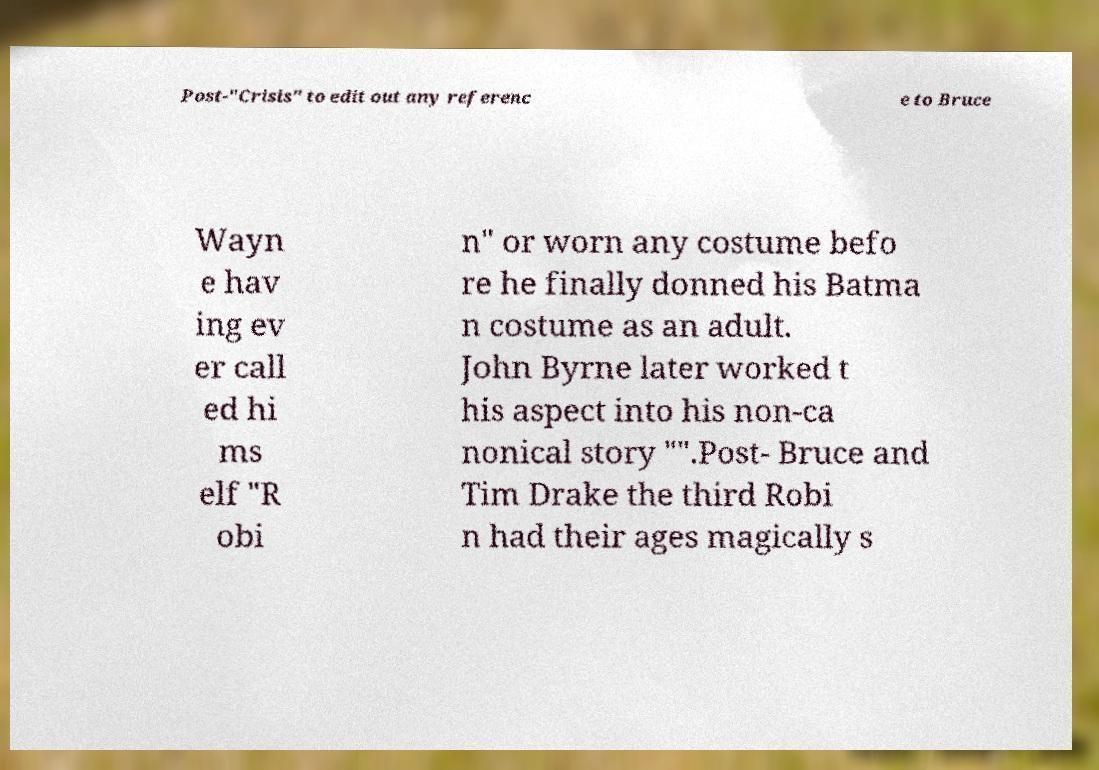Could you extract and type out the text from this image? Post-"Crisis" to edit out any referenc e to Bruce Wayn e hav ing ev er call ed hi ms elf "R obi n" or worn any costume befo re he finally donned his Batma n costume as an adult. John Byrne later worked t his aspect into his non-ca nonical story "".Post- Bruce and Tim Drake the third Robi n had their ages magically s 